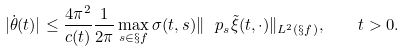<formula> <loc_0><loc_0><loc_500><loc_500>| \dot { \theta } ( t ) | \leq \frac { 4 \pi ^ { 2 } } { c ( t ) } \frac { 1 } { 2 \pi } \max _ { s \in \S f } \sigma ( t , s ) \| \ p _ { s } \tilde { \xi } ( t , \cdot ) \| _ { L ^ { 2 } ( \S f ) } , \quad t > 0 .</formula> 